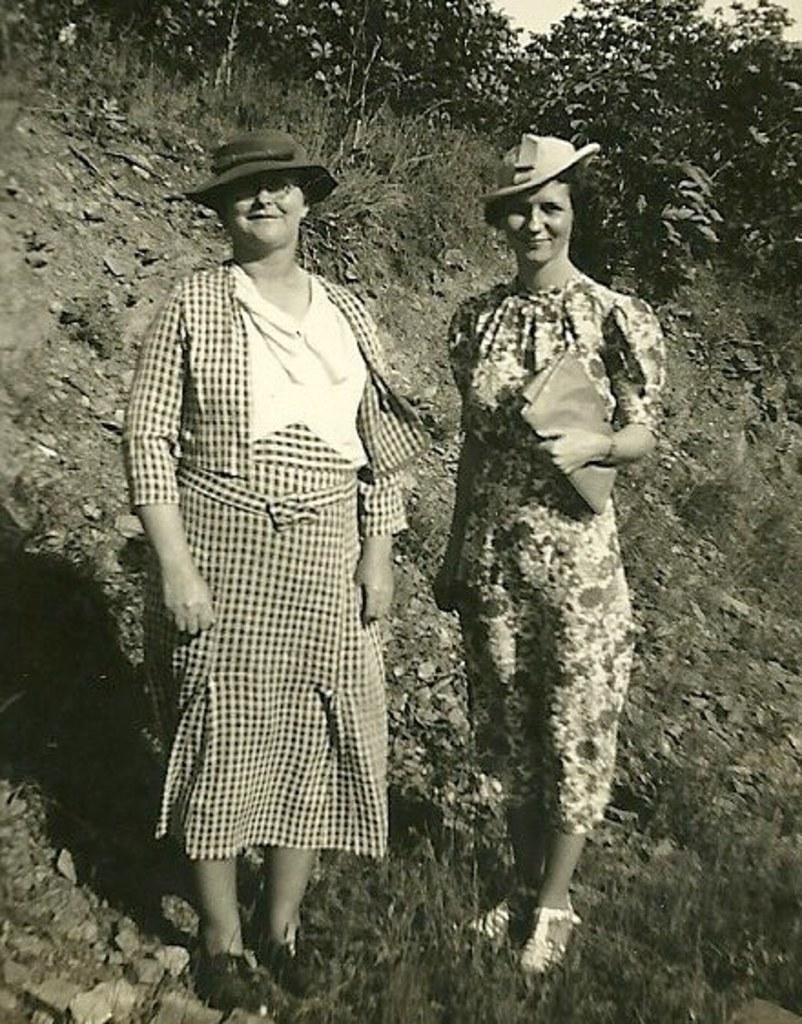Could you give a brief overview of what you see in this image? As we can see in the image in the front there are two women wearing hats and standing. In the background there are trees. There is grass and at the top there is sky. 